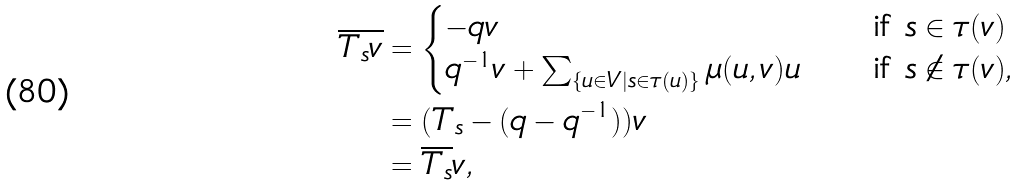<formula> <loc_0><loc_0><loc_500><loc_500>\overline { T _ { s } v } & = \begin{cases} - q v \quad & \text {if $s \in \tau(v)$} \\ q ^ { - 1 } v + \sum _ { \{ u \in V | s \in \tau ( u ) \} } \mu ( u , v ) u \quad & \text {if $s \notin \tau(v)$} , \end{cases} \\ & = ( T _ { s } - ( q - q ^ { - 1 } ) ) v \\ & = \overline { T _ { s } } v ,</formula> 